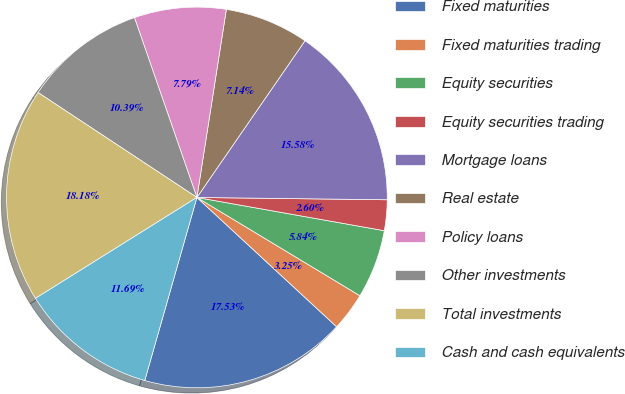Convert chart. <chart><loc_0><loc_0><loc_500><loc_500><pie_chart><fcel>Fixed maturities<fcel>Fixed maturities trading<fcel>Equity securities<fcel>Equity securities trading<fcel>Mortgage loans<fcel>Real estate<fcel>Policy loans<fcel>Other investments<fcel>Total investments<fcel>Cash and cash equivalents<nl><fcel>17.53%<fcel>3.25%<fcel>5.84%<fcel>2.6%<fcel>15.58%<fcel>7.14%<fcel>7.79%<fcel>10.39%<fcel>18.18%<fcel>11.69%<nl></chart> 